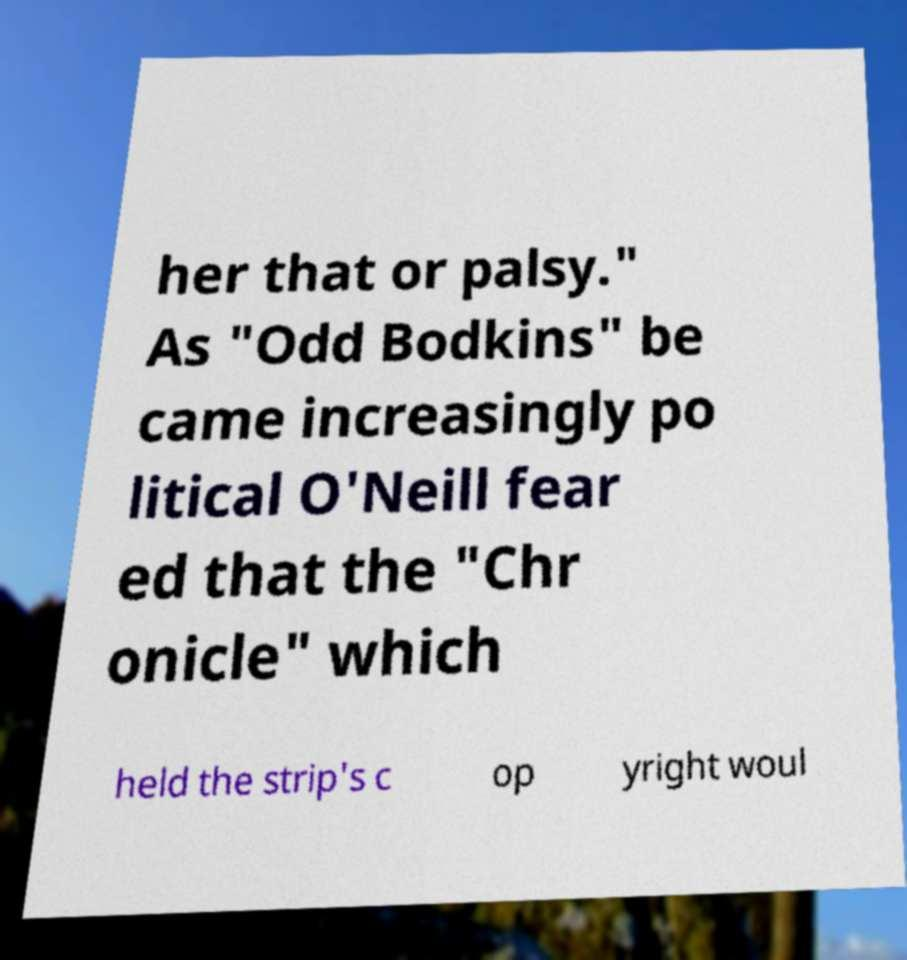I need the written content from this picture converted into text. Can you do that? her that or palsy." As "Odd Bodkins" be came increasingly po litical O'Neill fear ed that the "Chr onicle" which held the strip's c op yright woul 